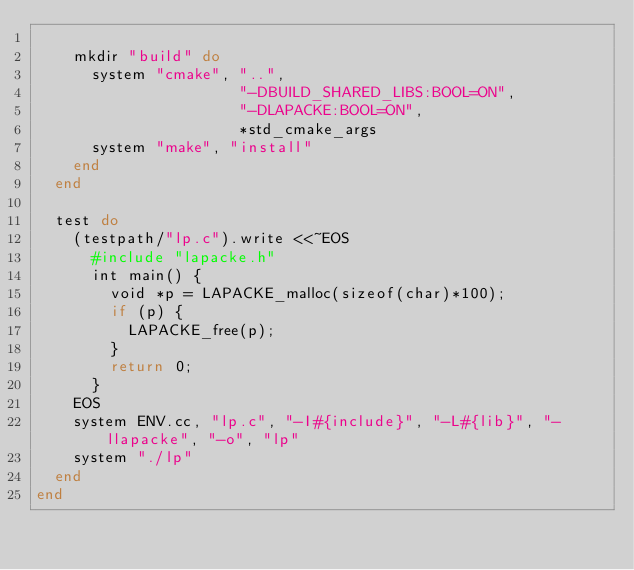Convert code to text. <code><loc_0><loc_0><loc_500><loc_500><_Ruby_>
    mkdir "build" do
      system "cmake", "..",
                      "-DBUILD_SHARED_LIBS:BOOL=ON",
                      "-DLAPACKE:BOOL=ON",
                      *std_cmake_args
      system "make", "install"
    end
  end

  test do
    (testpath/"lp.c").write <<~EOS
      #include "lapacke.h"
      int main() {
        void *p = LAPACKE_malloc(sizeof(char)*100);
        if (p) {
          LAPACKE_free(p);
        }
        return 0;
      }
    EOS
    system ENV.cc, "lp.c", "-I#{include}", "-L#{lib}", "-llapacke", "-o", "lp"
    system "./lp"
  end
end
</code> 